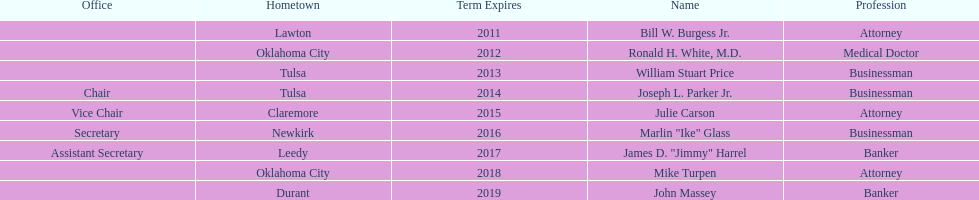How many of the current state regents will be in office until at least 2016? 4. 